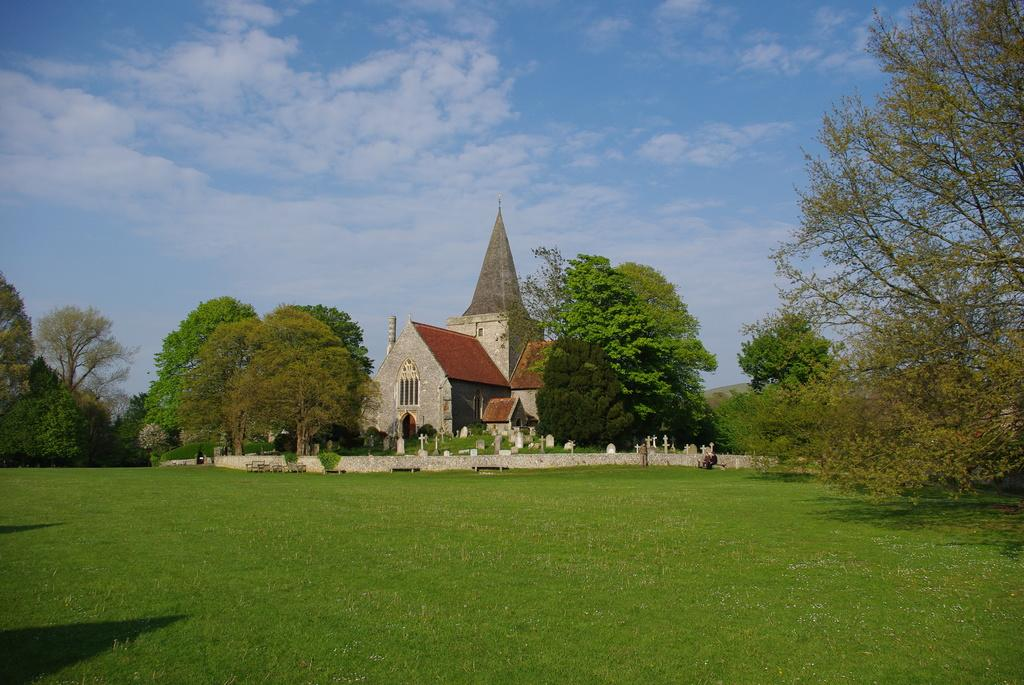What type of structure is visible in the image? There is a house in the image. What type of vegetation is present in the image? There are trees in the image. What type of outdoor area is visible in the image? There is a garden in the image. What type of vertical structures are present in the image? There are poles in the image. What is visible in the sky in the image? The sky is visible and cloudy in the image. What type of advertisement can be seen on the house in the image? There is no advertisement visible on the house in the image. What is the reaction of the trees to the weather in the image? The trees do not have a reaction in the image, as they are inanimate objects. 